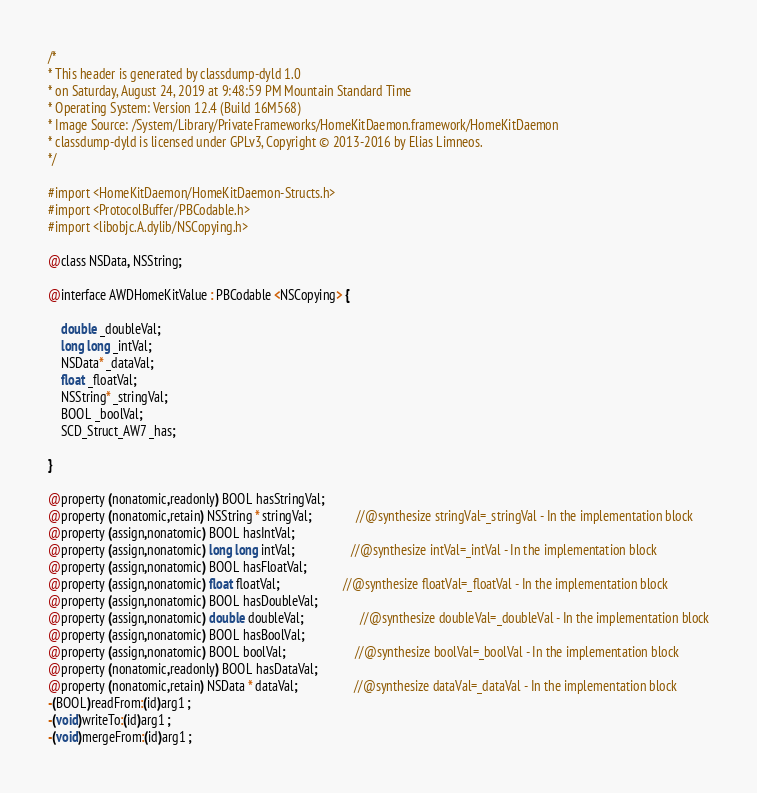<code> <loc_0><loc_0><loc_500><loc_500><_C_>/*
* This header is generated by classdump-dyld 1.0
* on Saturday, August 24, 2019 at 9:48:59 PM Mountain Standard Time
* Operating System: Version 12.4 (Build 16M568)
* Image Source: /System/Library/PrivateFrameworks/HomeKitDaemon.framework/HomeKitDaemon
* classdump-dyld is licensed under GPLv3, Copyright © 2013-2016 by Elias Limneos.
*/

#import <HomeKitDaemon/HomeKitDaemon-Structs.h>
#import <ProtocolBuffer/PBCodable.h>
#import <libobjc.A.dylib/NSCopying.h>

@class NSData, NSString;

@interface AWDHomeKitValue : PBCodable <NSCopying> {

	double _doubleVal;
	long long _intVal;
	NSData* _dataVal;
	float _floatVal;
	NSString* _stringVal;
	BOOL _boolVal;
	SCD_Struct_AW7 _has;

}

@property (nonatomic,readonly) BOOL hasStringVal; 
@property (nonatomic,retain) NSString * stringVal;              //@synthesize stringVal=_stringVal - In the implementation block
@property (assign,nonatomic) BOOL hasIntVal; 
@property (assign,nonatomic) long long intVal;                  //@synthesize intVal=_intVal - In the implementation block
@property (assign,nonatomic) BOOL hasFloatVal; 
@property (assign,nonatomic) float floatVal;                    //@synthesize floatVal=_floatVal - In the implementation block
@property (assign,nonatomic) BOOL hasDoubleVal; 
@property (assign,nonatomic) double doubleVal;                  //@synthesize doubleVal=_doubleVal - In the implementation block
@property (assign,nonatomic) BOOL hasBoolVal; 
@property (assign,nonatomic) BOOL boolVal;                      //@synthesize boolVal=_boolVal - In the implementation block
@property (nonatomic,readonly) BOOL hasDataVal; 
@property (nonatomic,retain) NSData * dataVal;                  //@synthesize dataVal=_dataVal - In the implementation block
-(BOOL)readFrom:(id)arg1 ;
-(void)writeTo:(id)arg1 ;
-(void)mergeFrom:(id)arg1 ;</code> 